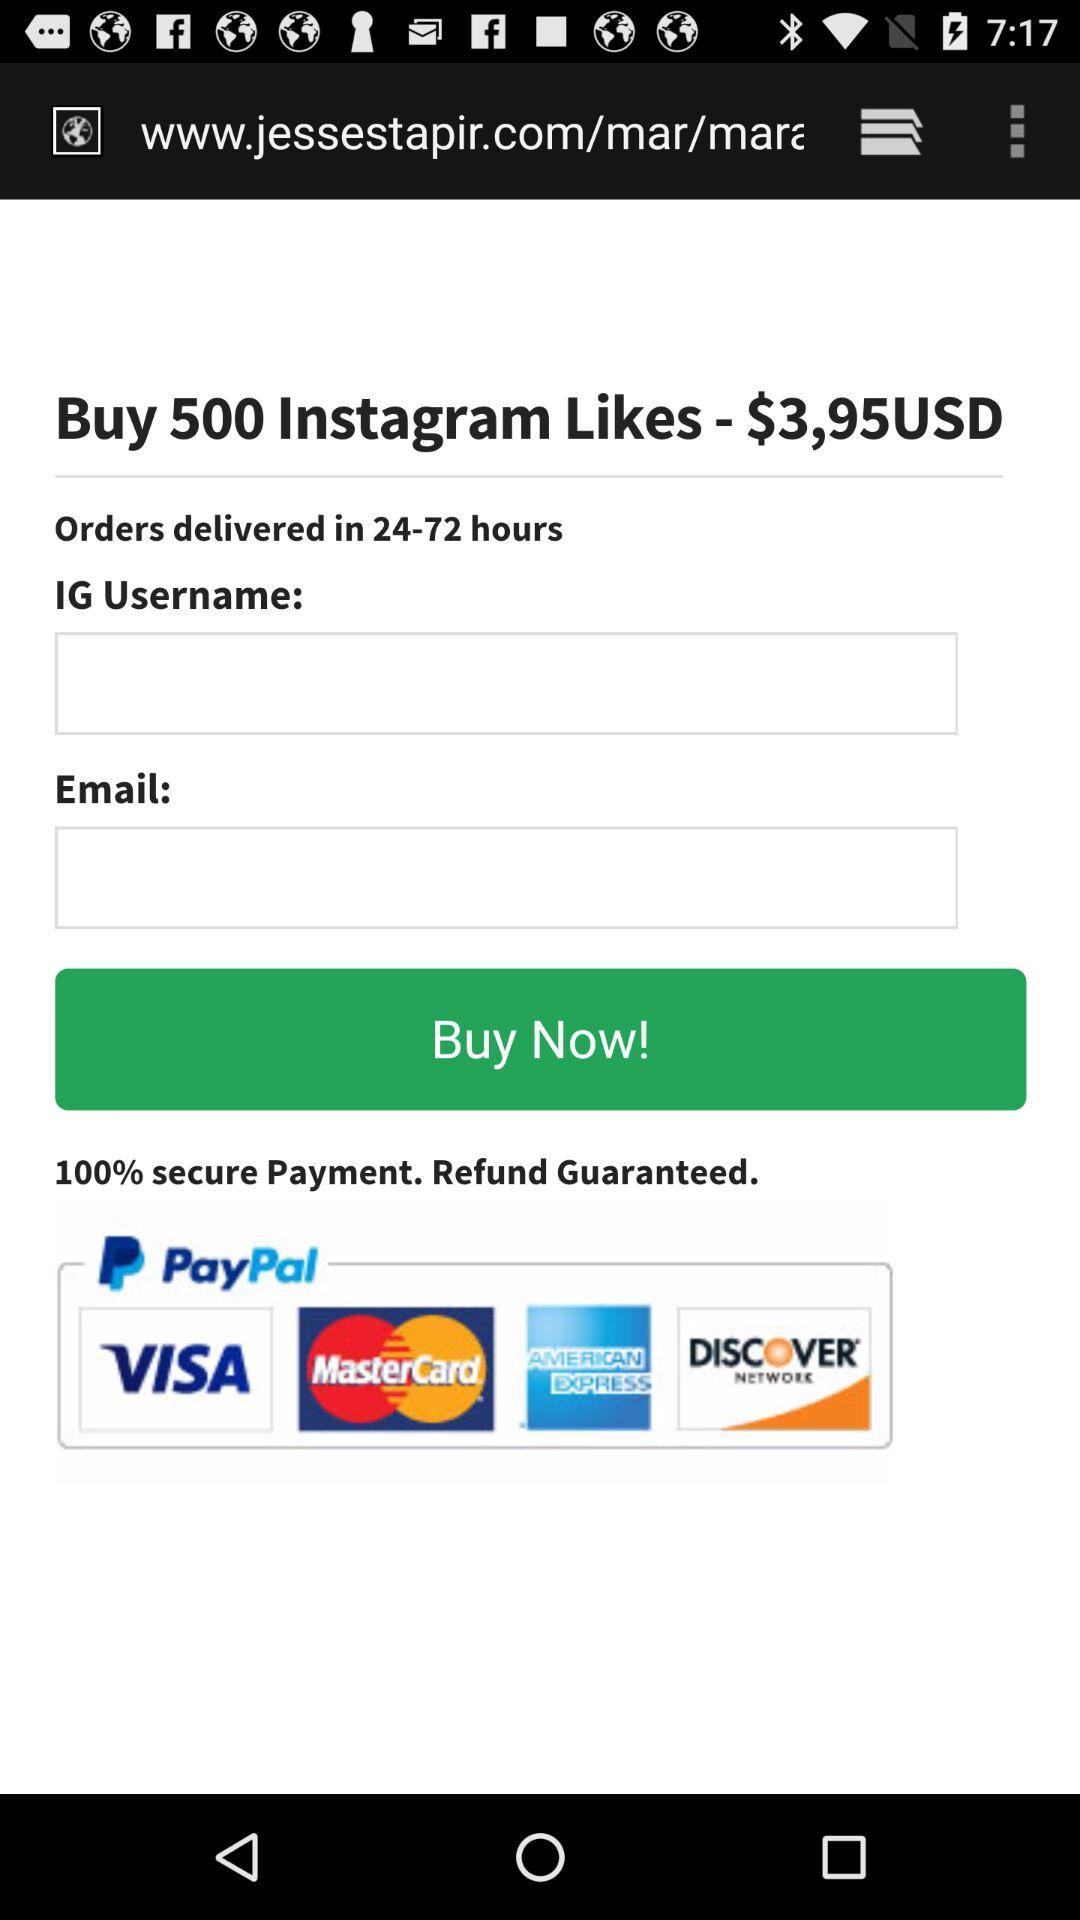What's the order delivery duration? The order delivery duration is 24–72 hours. 